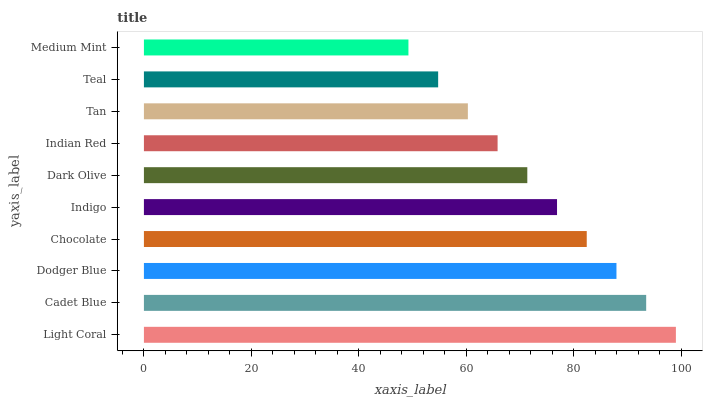Is Medium Mint the minimum?
Answer yes or no. Yes. Is Light Coral the maximum?
Answer yes or no. Yes. Is Cadet Blue the minimum?
Answer yes or no. No. Is Cadet Blue the maximum?
Answer yes or no. No. Is Light Coral greater than Cadet Blue?
Answer yes or no. Yes. Is Cadet Blue less than Light Coral?
Answer yes or no. Yes. Is Cadet Blue greater than Light Coral?
Answer yes or no. No. Is Light Coral less than Cadet Blue?
Answer yes or no. No. Is Indigo the high median?
Answer yes or no. Yes. Is Dark Olive the low median?
Answer yes or no. Yes. Is Dodger Blue the high median?
Answer yes or no. No. Is Indian Red the low median?
Answer yes or no. No. 